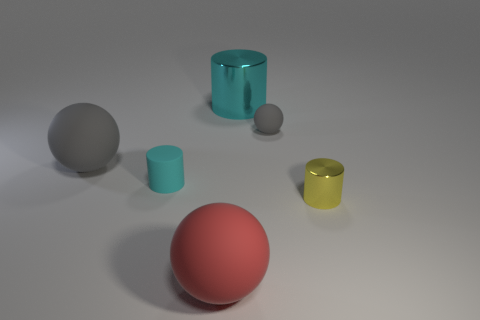Do the matte cylinder and the red rubber thing have the same size?
Offer a terse response. No. What number of other objects are the same shape as the small cyan thing?
Offer a very short reply. 2. What color is the metal cylinder in front of the big cyan cylinder?
Make the answer very short. Yellow. What number of cylinders are to the left of the small rubber object behind the large matte object behind the yellow shiny cylinder?
Your response must be concise. 2. There is a gray sphere in front of the small rubber ball; how many yellow cylinders are behind it?
Make the answer very short. 0. There is a tiny gray rubber ball; what number of metallic objects are on the right side of it?
Ensure brevity in your answer.  1. How many other things are there of the same size as the red sphere?
Make the answer very short. 2. There is another cyan thing that is the same shape as the cyan matte object; what is its size?
Give a very brief answer. Large. There is a object that is in front of the small metallic object; what shape is it?
Provide a short and direct response. Sphere. What color is the cylinder to the right of the gray object that is right of the large cylinder?
Keep it short and to the point. Yellow. 